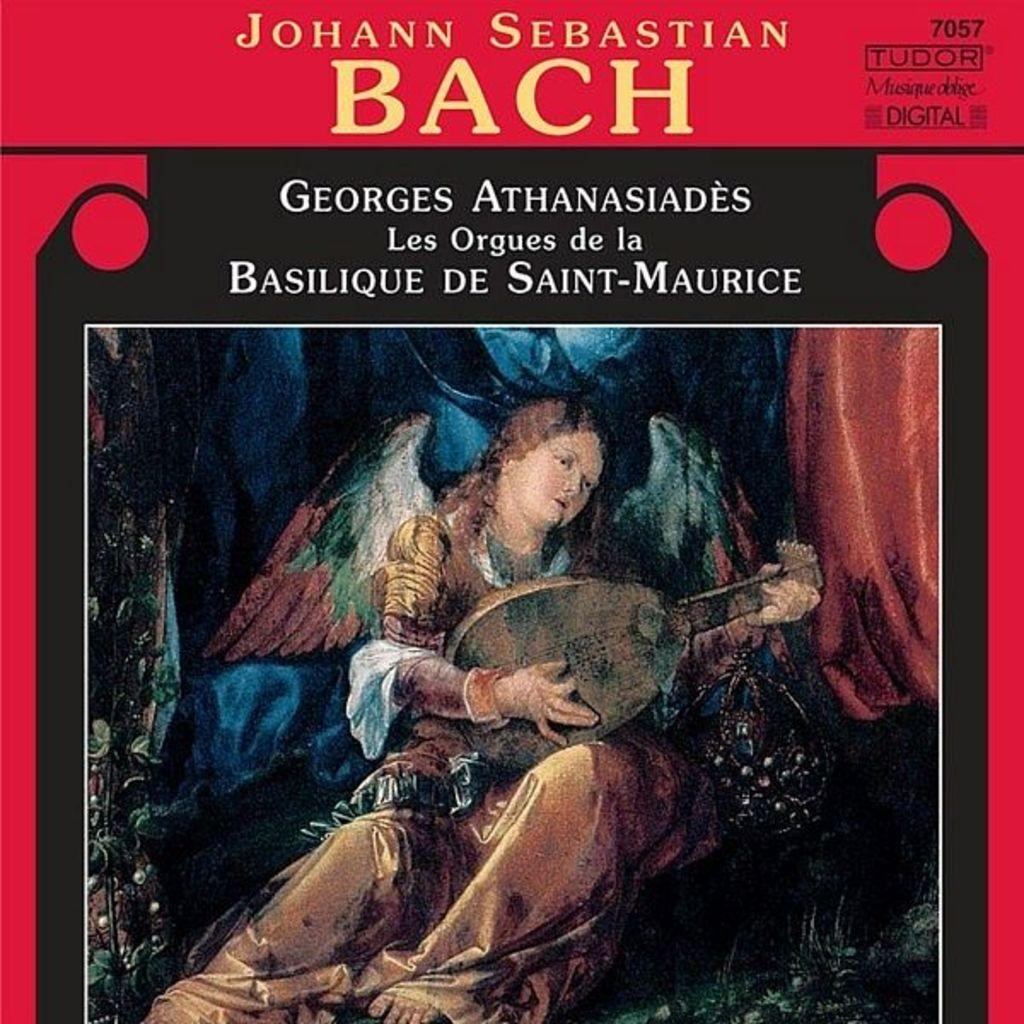What is the main subject of the image? There is a person in the image. What is the person doing in the image? The person is playing a musical instrument. Is there any text present in the image? Yes, there is text at the top of the image. Can you tell me how many volcanoes are mentioned in the text at the top of the image? There are no volcanoes mentioned in the text at the top of the image, as the provided facts do not mention any volcanoes. 